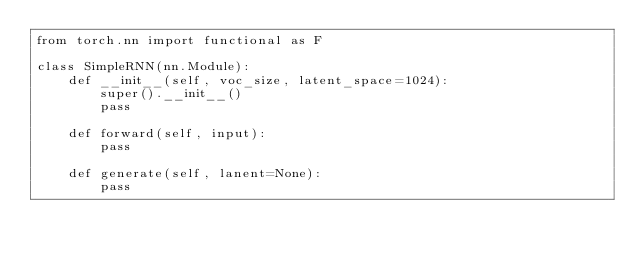<code> <loc_0><loc_0><loc_500><loc_500><_Python_>from torch.nn import functional as F

class SimpleRNN(nn.Module):    
    def __init__(self, voc_size, latent_space=1024):
        super().__init__()
        pass

    def forward(self, input):
        pass

    def generate(self, lanent=None):
        pass
</code> 